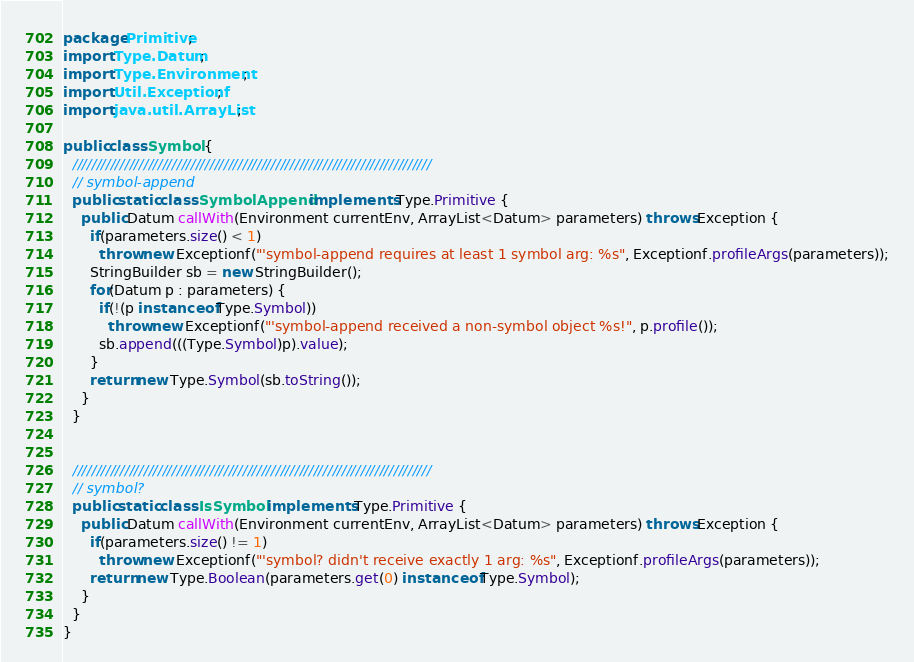Convert code to text. <code><loc_0><loc_0><loc_500><loc_500><_Java_>package Primitive;
import Type.Datum;
import Type.Environment;
import Util.Exceptionf;
import java.util.ArrayList;

public class Symbol {
  ////////////////////////////////////////////////////////////////////////////
  // symbol-append
  public static class SymbolAppend implements Type.Primitive {
    public Datum callWith(Environment currentEnv, ArrayList<Datum> parameters) throws Exception {
      if(parameters.size() < 1) 
        throw new Exceptionf("'symbol-append requires at least 1 symbol arg: %s", Exceptionf.profileArgs(parameters));
      StringBuilder sb = new StringBuilder();
      for(Datum p : parameters) {
        if(!(p instanceof Type.Symbol))
          throw new Exceptionf("'symbol-append received a non-symbol object %s!", p.profile());
        sb.append(((Type.Symbol)p).value);
      }
      return new Type.Symbol(sb.toString());
    }
  }


  ////////////////////////////////////////////////////////////////////////////
  // symbol?
  public static class IsSymbol implements Type.Primitive {
    public Datum callWith(Environment currentEnv, ArrayList<Datum> parameters) throws Exception {
      if(parameters.size() != 1) 
        throw new Exceptionf("'symbol? didn't receive exactly 1 arg: %s", Exceptionf.profileArgs(parameters));
      return new Type.Boolean(parameters.get(0) instanceof Type.Symbol);
    }
  }
}</code> 